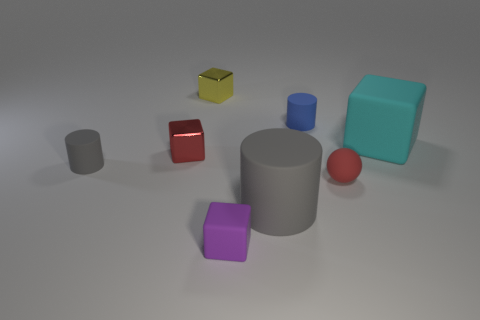Does the matte ball have the same color as the small metal object left of the yellow block?
Your answer should be very brief. Yes. What number of tiny blue objects have the same material as the large cube?
Your answer should be compact. 1. There is a large object to the right of the large cylinder; is it the same shape as the tiny rubber object in front of the large cylinder?
Give a very brief answer. Yes. There is a large rubber thing that is in front of the cyan matte block; what is its color?
Offer a very short reply. Gray. Is there a blue rubber thing of the same shape as the small gray object?
Provide a short and direct response. Yes. What is the small red block made of?
Your answer should be very brief. Metal. How big is the cube that is both right of the red cube and in front of the large block?
Provide a succinct answer. Small. What is the material of the cube that is the same color as the small sphere?
Ensure brevity in your answer.  Metal. How many tiny red rubber objects are there?
Your response must be concise. 1. Are there fewer blue matte things than large purple cylinders?
Give a very brief answer. No. 